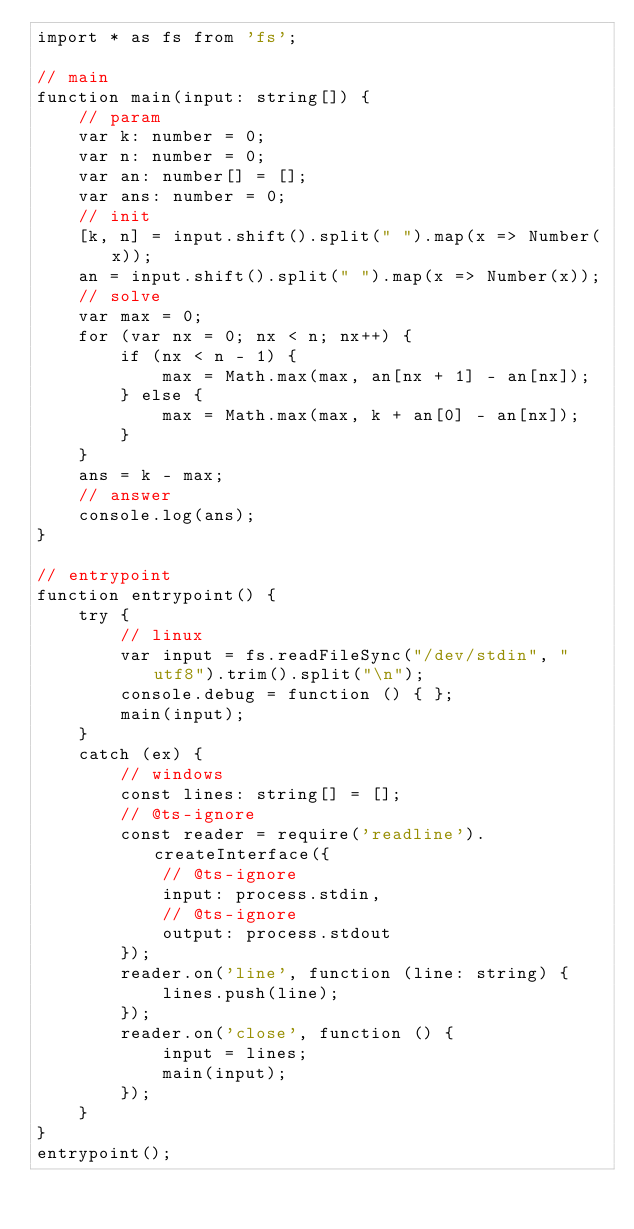Convert code to text. <code><loc_0><loc_0><loc_500><loc_500><_TypeScript_>import * as fs from 'fs';

// main
function main(input: string[]) {
    // param
    var k: number = 0;
    var n: number = 0;
    var an: number[] = [];
    var ans: number = 0;
    // init
    [k, n] = input.shift().split(" ").map(x => Number(x));
    an = input.shift().split(" ").map(x => Number(x));
    // solve
    var max = 0;
    for (var nx = 0; nx < n; nx++) {
        if (nx < n - 1) {
            max = Math.max(max, an[nx + 1] - an[nx]);
        } else {
            max = Math.max(max, k + an[0] - an[nx]);
        }
    }
    ans = k - max;
    // answer
    console.log(ans);
}

// entrypoint
function entrypoint() {
    try {
        // linux
        var input = fs.readFileSync("/dev/stdin", "utf8").trim().split("\n");
        console.debug = function () { };
        main(input);
    }
    catch (ex) {
        // windows
        const lines: string[] = [];
        // @ts-ignore
        const reader = require('readline').createInterface({
            // @ts-ignore
            input: process.stdin,
            // @ts-ignore
            output: process.stdout
        });
        reader.on('line', function (line: string) {
            lines.push(line);
        });
        reader.on('close', function () {
            input = lines;
            main(input);
        });
    }
}
entrypoint();
</code> 